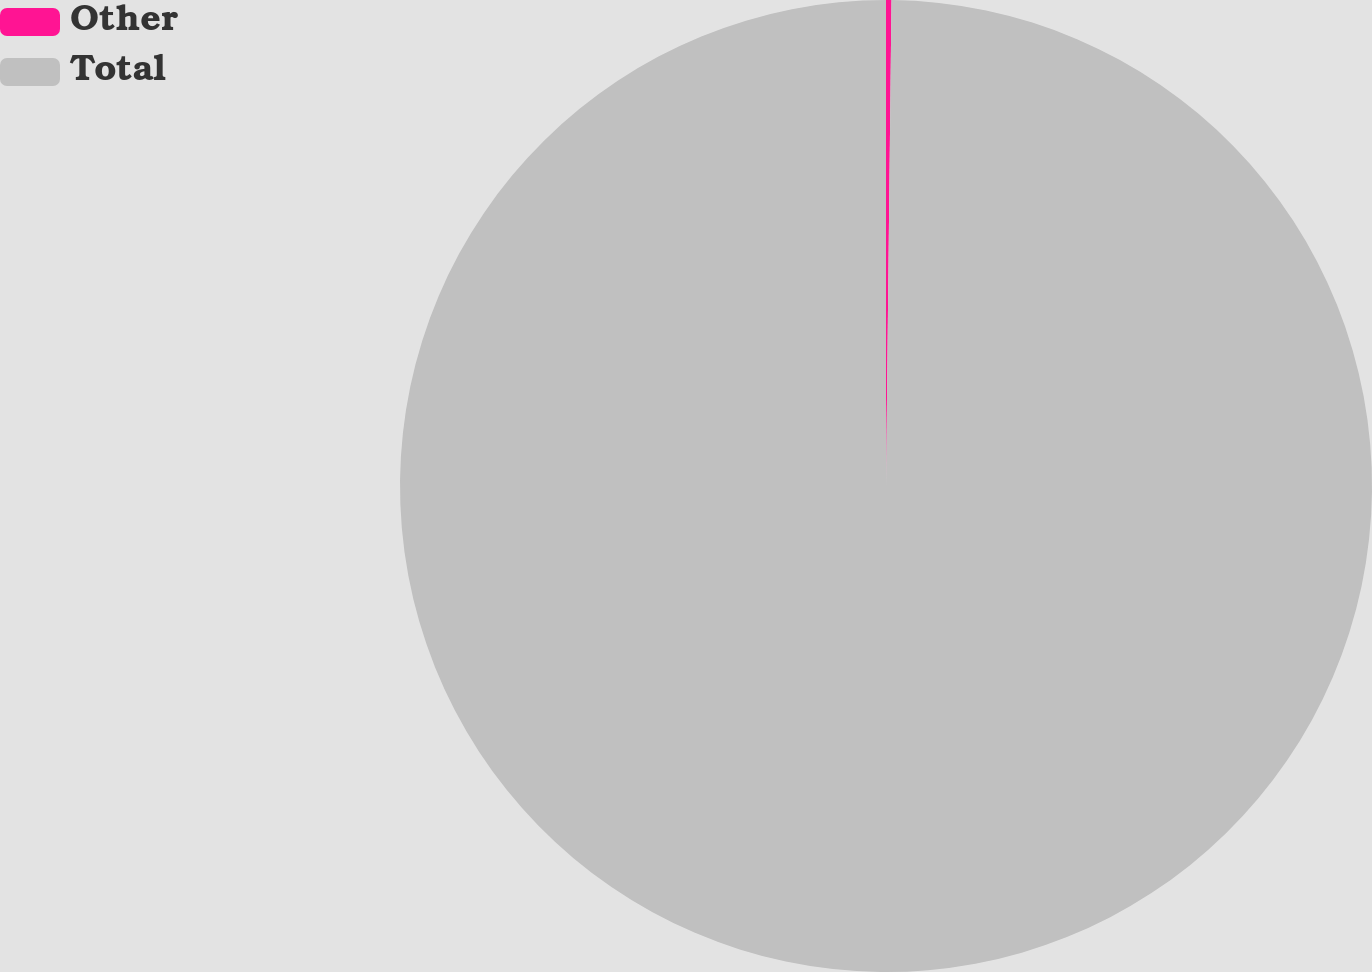Convert chart. <chart><loc_0><loc_0><loc_500><loc_500><pie_chart><fcel>Other<fcel>Total<nl><fcel>0.18%<fcel>99.82%<nl></chart> 